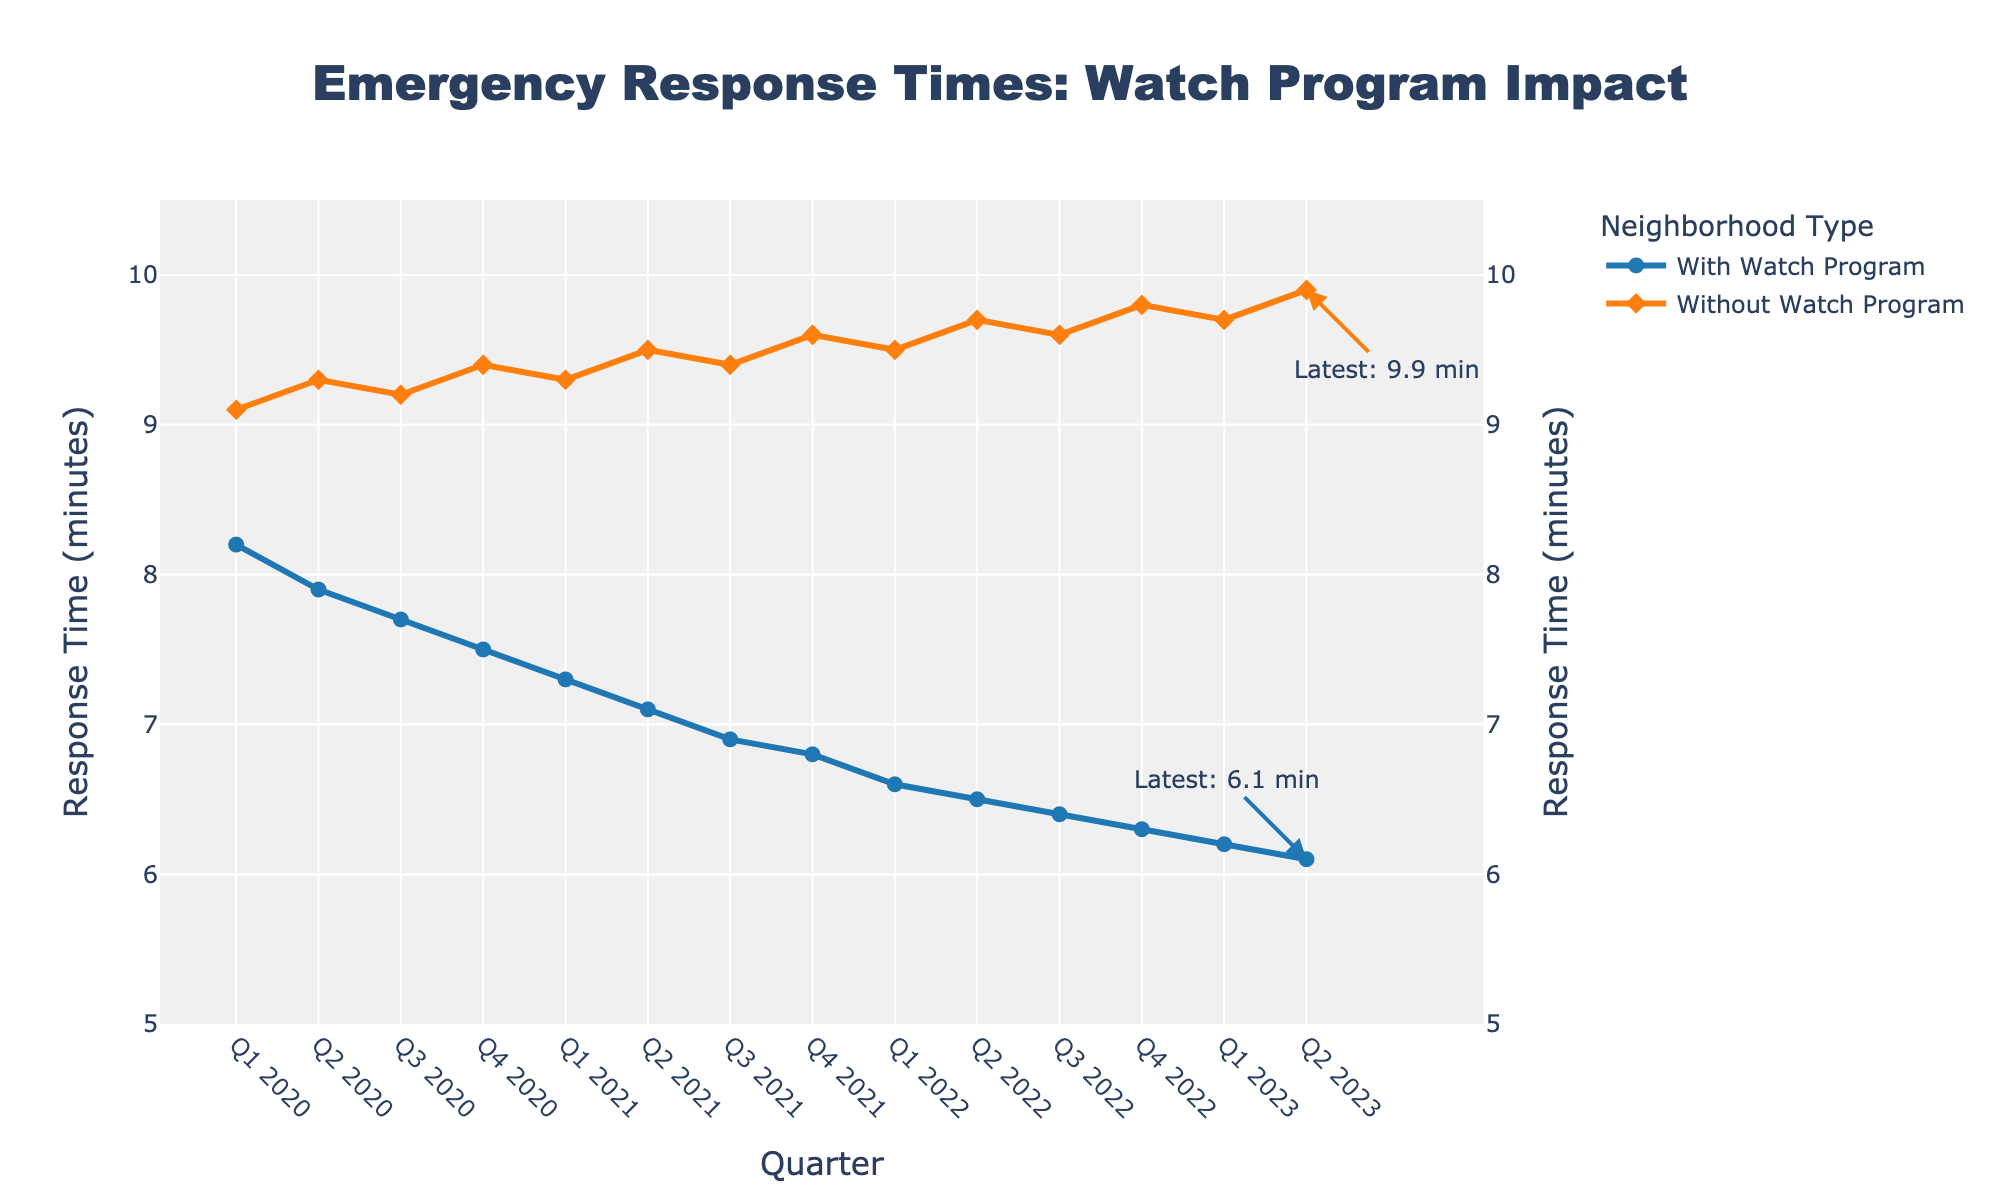What's the trend of emergency response times with a watch program from Q1 2020 to Q2 2023? The plot shows the emergency response times with a watch program decreasing from 8.2 minutes in Q1 2020 to 6.1 minutes in Q2 2023. This downward trend indicates an improvement in response times over the quarters.
Answer: Decreasing What's the biggest difference in response times between neighborhoods with and without a watch program in any quarter? The largest difference can be found by comparing the two lines at each quarter. In Q2 2023, "With Watch Program" is 6.1 minutes and "Without Watch Program" is 9.9 minutes, making the difference 3.8 minutes, which is the largest observed difference.
Answer: 3.8 minutes What quarter showed the smallest response time for neighborhoods with a watch program? From the plot, the lowest point on the "With Watch Program" line is at Q2 2023, which is 6.1 minutes.
Answer: Q2 2023 Is there any quarter where the response time without a watch program decreased? Observing the plot, the line representing "Without Watch Program" generally shows an increasing trend from 9.1 minutes in Q1 2020 to 9.9 minutes in Q2 2023; no quarter shows a decrease.
Answer: No Which quarter had the highest response time for neighborhoods without a watch program? The plot shows the peak point on the "Without Watch Program" line in Q2 2023, where the response time is 9.9 minutes.
Answer: Q2 2023 